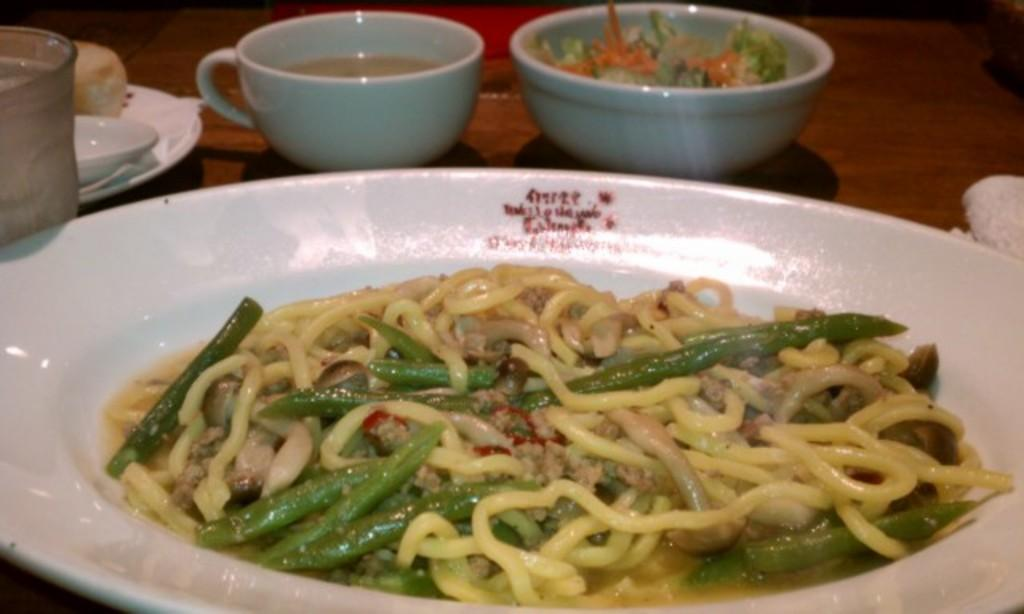What type of furniture is present in the image? The image contains a table. What objects are placed on the table? There is a plate, a bowl, and a cup on the table. Can you describe the contents of the image? There is food visible in the image. What type of picture can be seen hanging on the wall in the image? There is no picture hanging on the wall in the image; it only contains a table with a plate, a bowl, a cup, and food. 